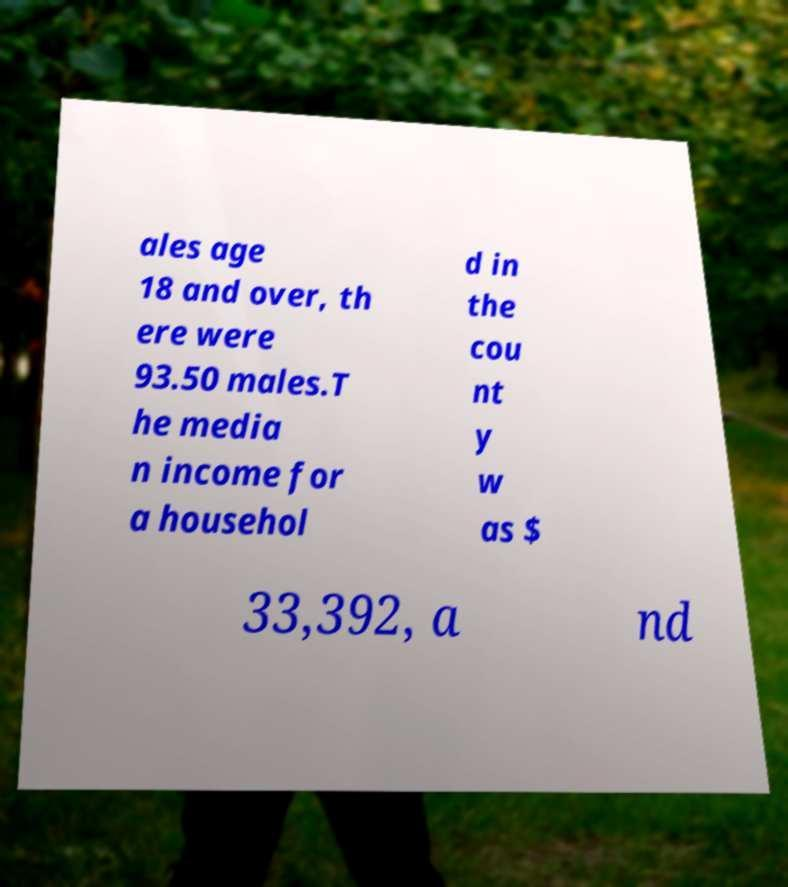Could you assist in decoding the text presented in this image and type it out clearly? ales age 18 and over, th ere were 93.50 males.T he media n income for a househol d in the cou nt y w as $ 33,392, a nd 